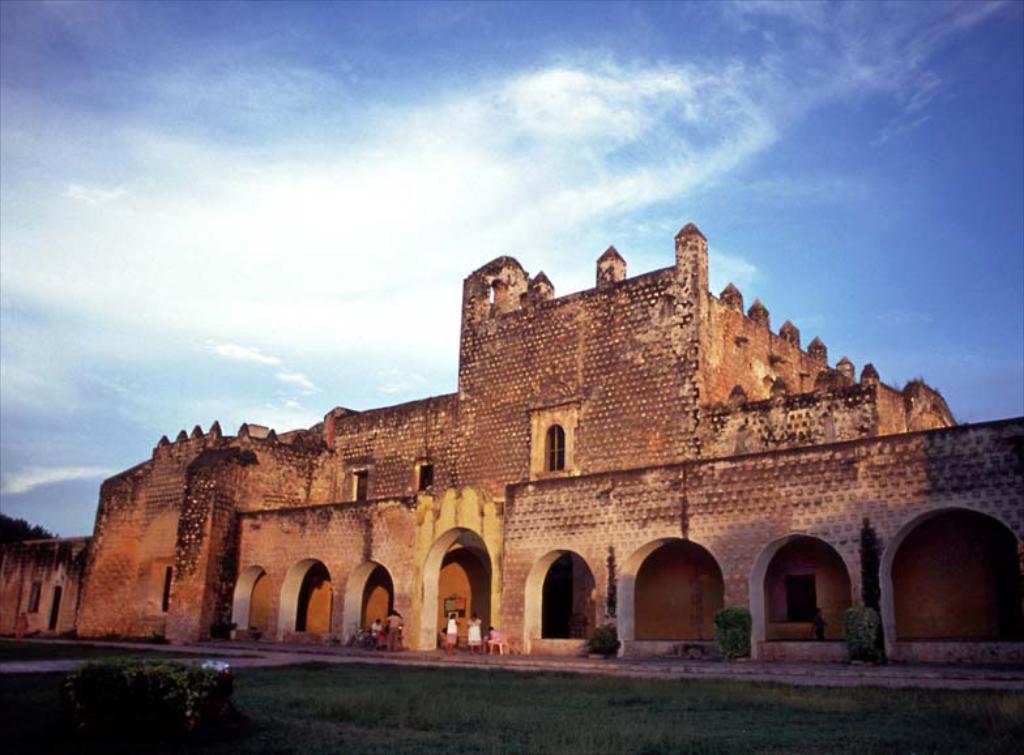Can you describe this image briefly? In this picture I see the grass and the plants in front and in the middle of this picture I see a building and I see few people. In the background I see the clear sky. 